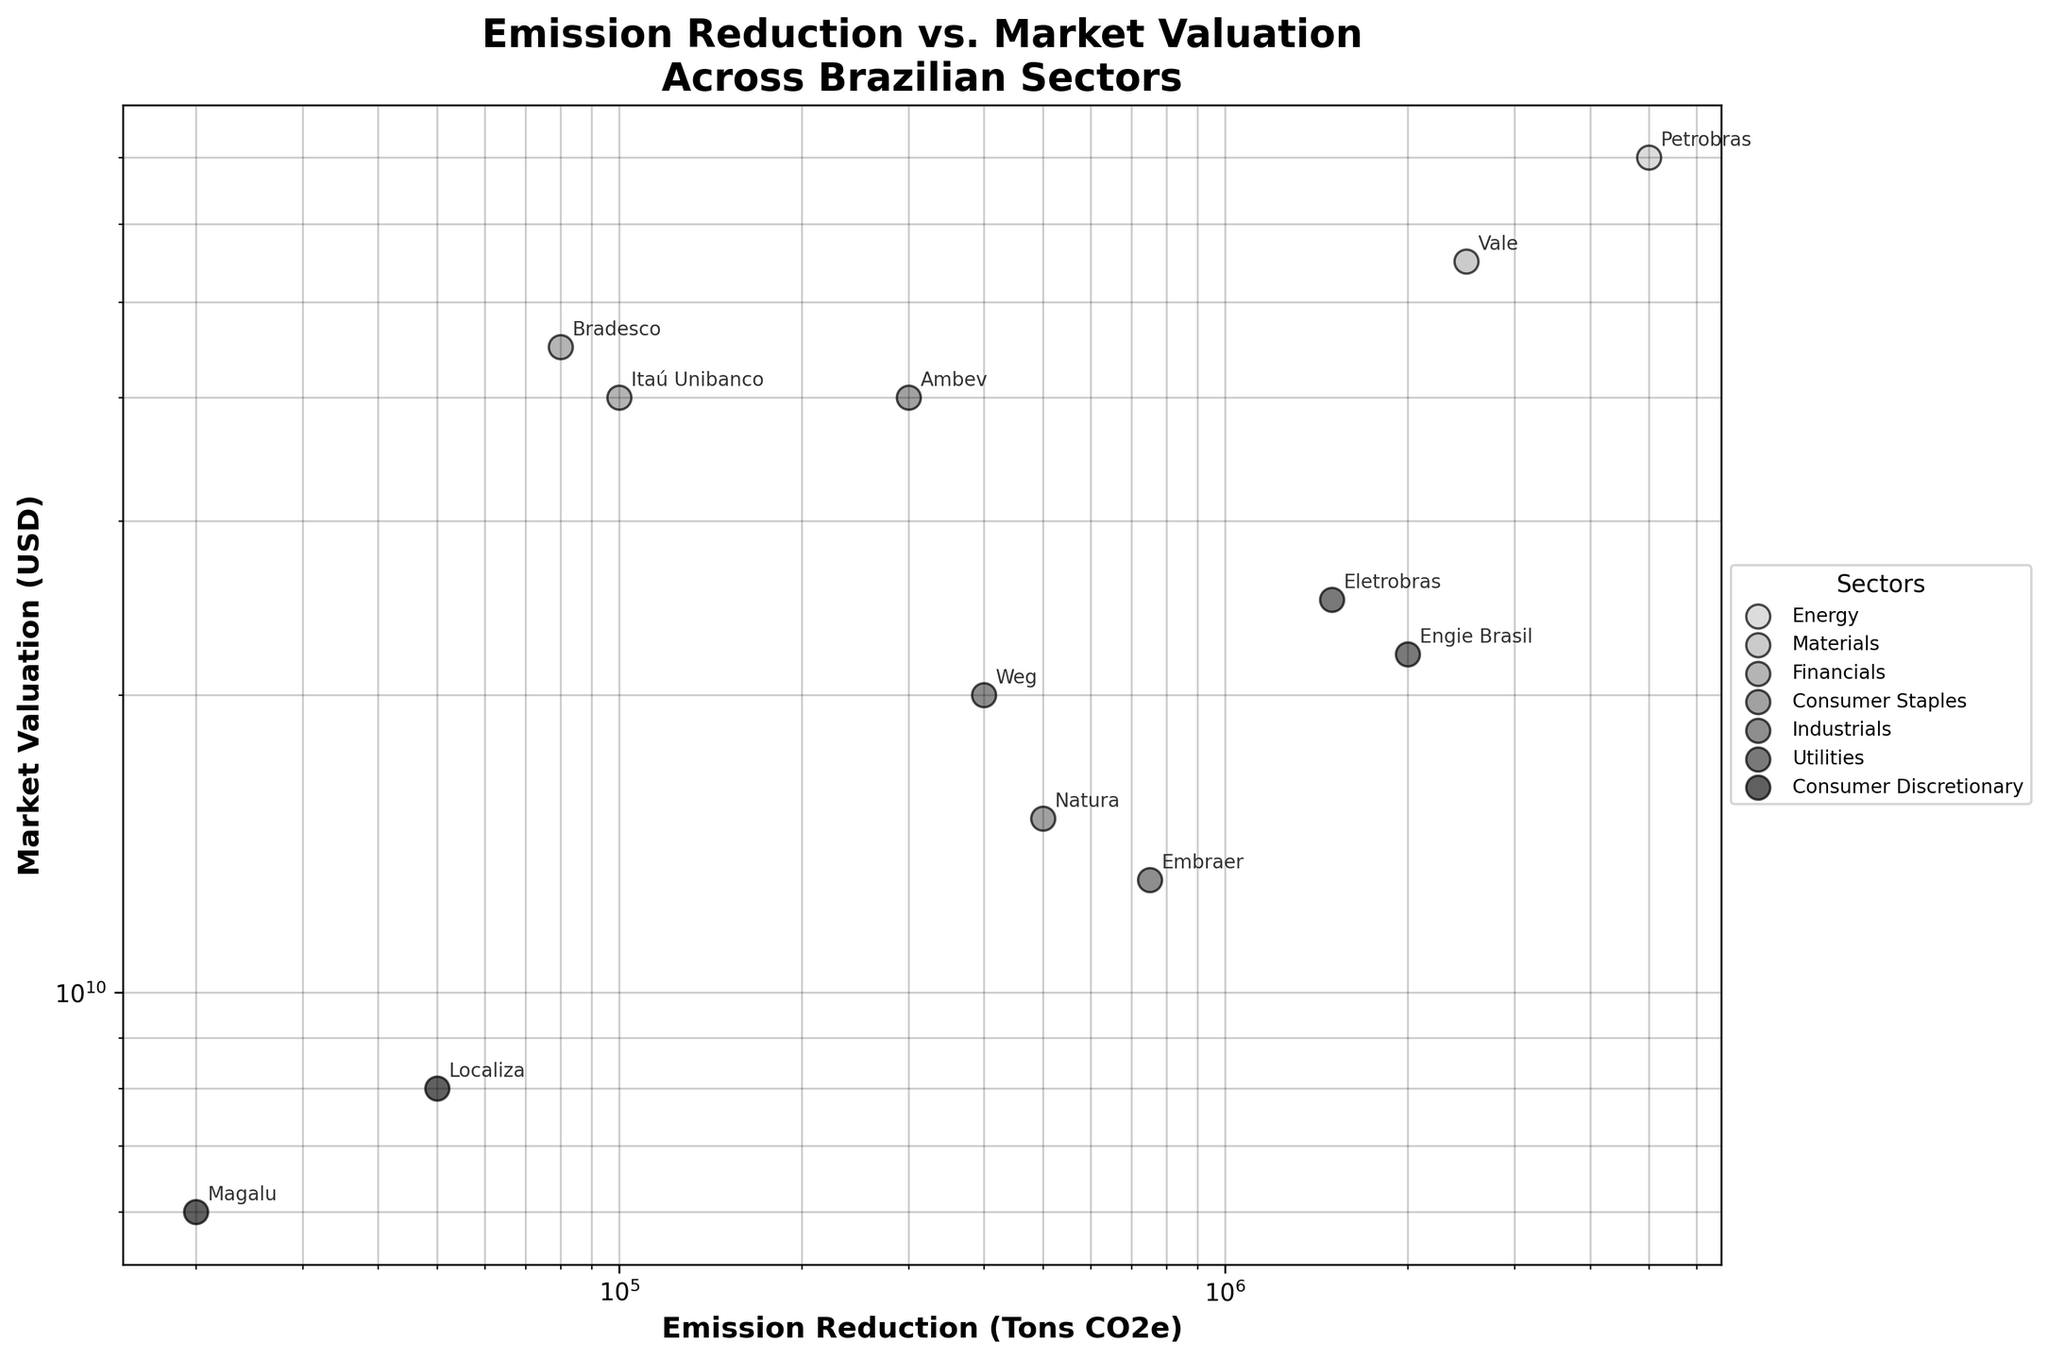What are the sectors included in the plot? The plot legend shows the names of all sectors represented in the scatter plot. By checking the legend, we can identify the sectors shown.
Answer: Energy, Materials, Financials, Consumer Staples, Industrials, Utilities, Consumer Discretionary Which company has the highest market valuation? By examining the y-axis in the scatter plot, we can identify the point with the highest value on the log scale and find the corresponding company label.
Answer: Petrobras Which sector has the most companies represented in the plot? By counting the number of companies (points) associated with each sector, as indicated in the plot legend and labels, we can determine which sector has the most representation.
Answer: Financials What is the emission reduction of Ambev in Tons CO2e? Locate the point corresponding to Ambev and read the x-axis value on the log scale for emission reduction.
Answer: 300,000 Which company in the Utilities sector has a higher market valuation? Compare the y-axis positions (market valuations) for the two companies in the Utilities sector (Eletrobras and Engie Brasil).
Answer: Eletrobras What is the difference in market valuation between Itaú Unibanco and Bradesco? Find the y-axis values for both Itaú Unibanco and Bradesco and subtract one from the other.
Answer: 5,000,000,000 USD How do the companies in the Consumer Discretionary sector compare in terms of emission reduction? Look at the x-axis positions for Magalu and Localiza in the Consumer Discretionary sector to see which has higher and lower emissions reductions.
Answer: Magalu < Localiza Which company shows a combination of high emission reduction and high market valuation in the Energy sector? In the Energy sector, check the plot for the company positioned farthest to the right (high emission reduction) and towards the top (high market valuation).
Answer: Petrobras Is there a sector with a company that has both low emission reduction and low market valuation? Scan the lower left quadrant of the scatter plot, examining company labels and their associated sectors to identify any such company.
Answer: Magalu, Consumer Discretionary What’s the median emission reduction of companies in the Utilities sector? List the emission reductions for both companies in the Utilities sector (1,500,000 and 2,000,000 Tons CO2e), and find the median value.
Answer: 1,750,000 